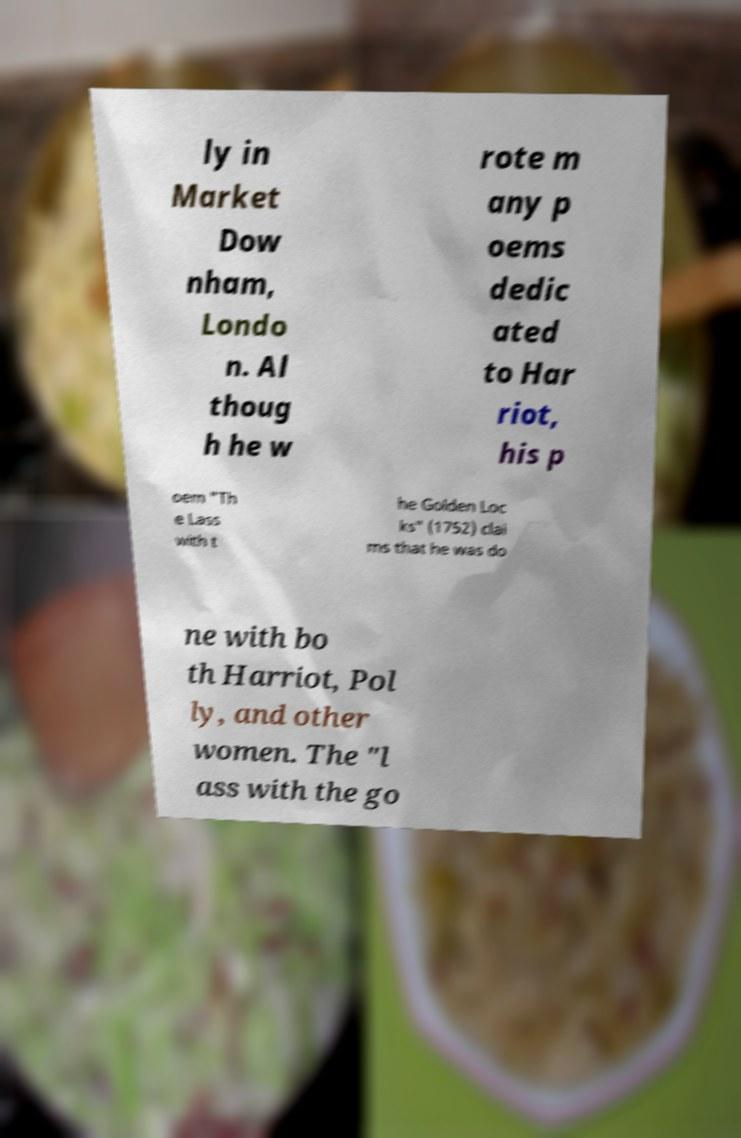What messages or text are displayed in this image? I need them in a readable, typed format. ly in Market Dow nham, Londo n. Al thoug h he w rote m any p oems dedic ated to Har riot, his p oem "Th e Lass with t he Golden Loc ks" (1752) clai ms that he was do ne with bo th Harriot, Pol ly, and other women. The "l ass with the go 